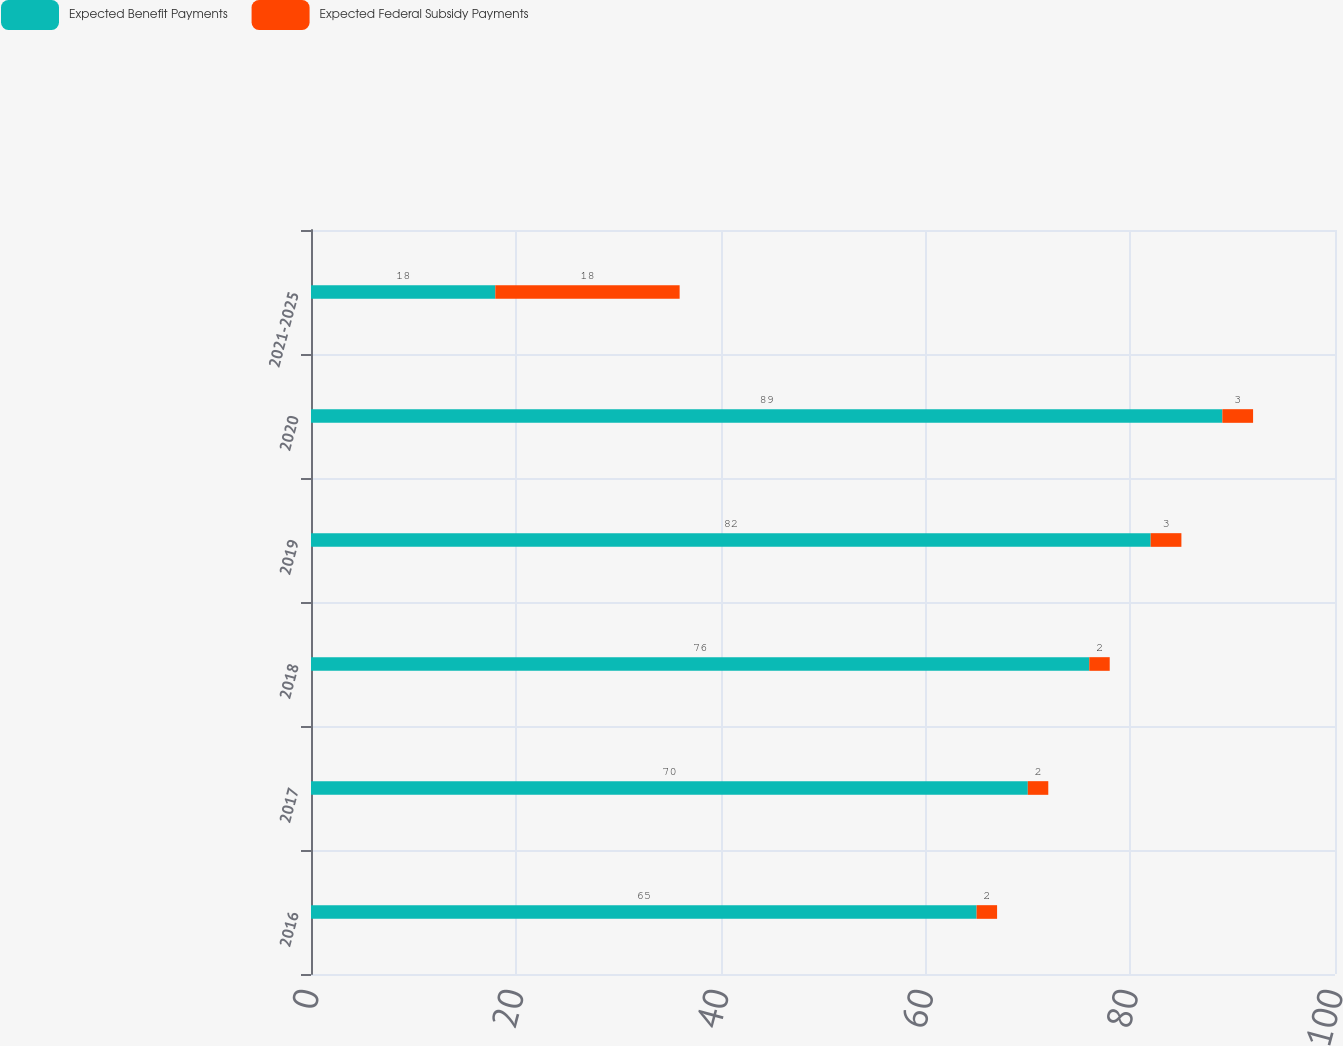Convert chart to OTSL. <chart><loc_0><loc_0><loc_500><loc_500><stacked_bar_chart><ecel><fcel>2016<fcel>2017<fcel>2018<fcel>2019<fcel>2020<fcel>2021-2025<nl><fcel>Expected Benefit Payments<fcel>65<fcel>70<fcel>76<fcel>82<fcel>89<fcel>18<nl><fcel>Expected Federal Subsidy Payments<fcel>2<fcel>2<fcel>2<fcel>3<fcel>3<fcel>18<nl></chart> 